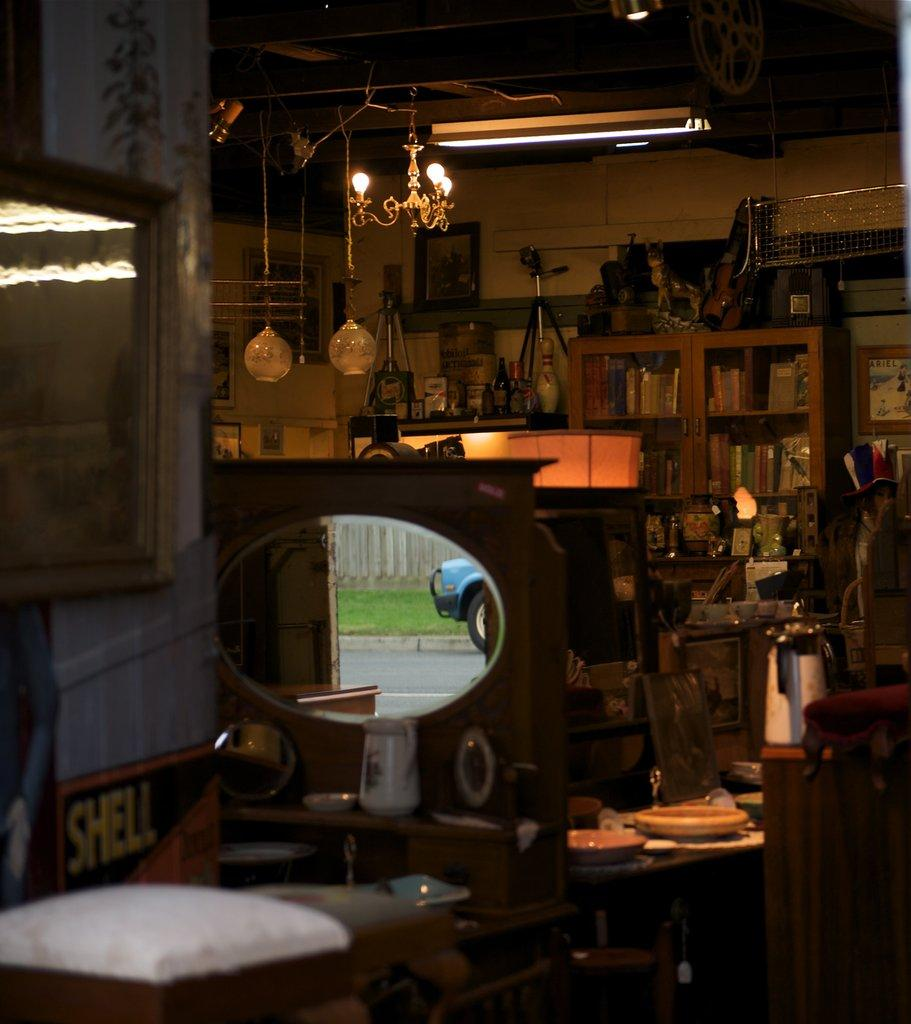Where was the image taken? The image was taken in a store. What can be found in the store? There are mirrors, chairs, a wall, lights, a ceiling, bottles, tripod stands, frames, a jar, a table, and a cupboard in the store. Can you see a boundary between the store and the outside world in the image? There is no boundary visible in the image, as it only shows the interior of the store. Is there a man using a whip in the store in the image? There is no man or whip present in the image; it only shows various objects and items in the store. 